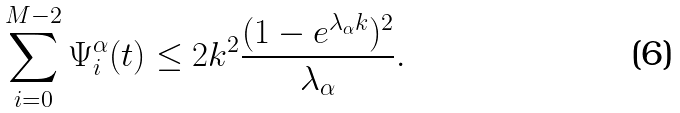<formula> <loc_0><loc_0><loc_500><loc_500>\sum _ { i = 0 } ^ { M - 2 } \Psi _ { i } ^ { \alpha } ( t ) & \leq 2 k ^ { 2 } \frac { ( 1 - e ^ { \lambda _ { \alpha } k } ) ^ { 2 } } { \lambda _ { \alpha } } .</formula> 